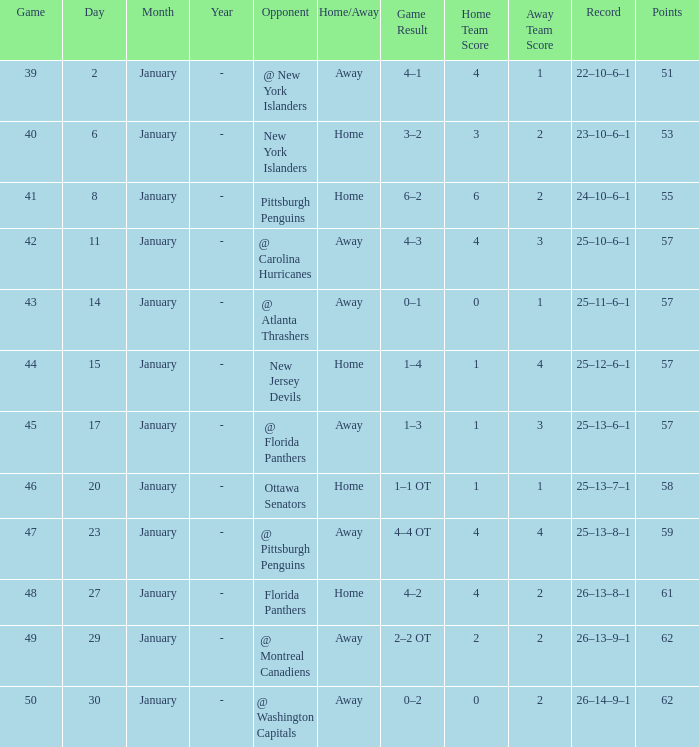What opponent has an average less than 62 and a january average less than 6 @ New York Islanders. 